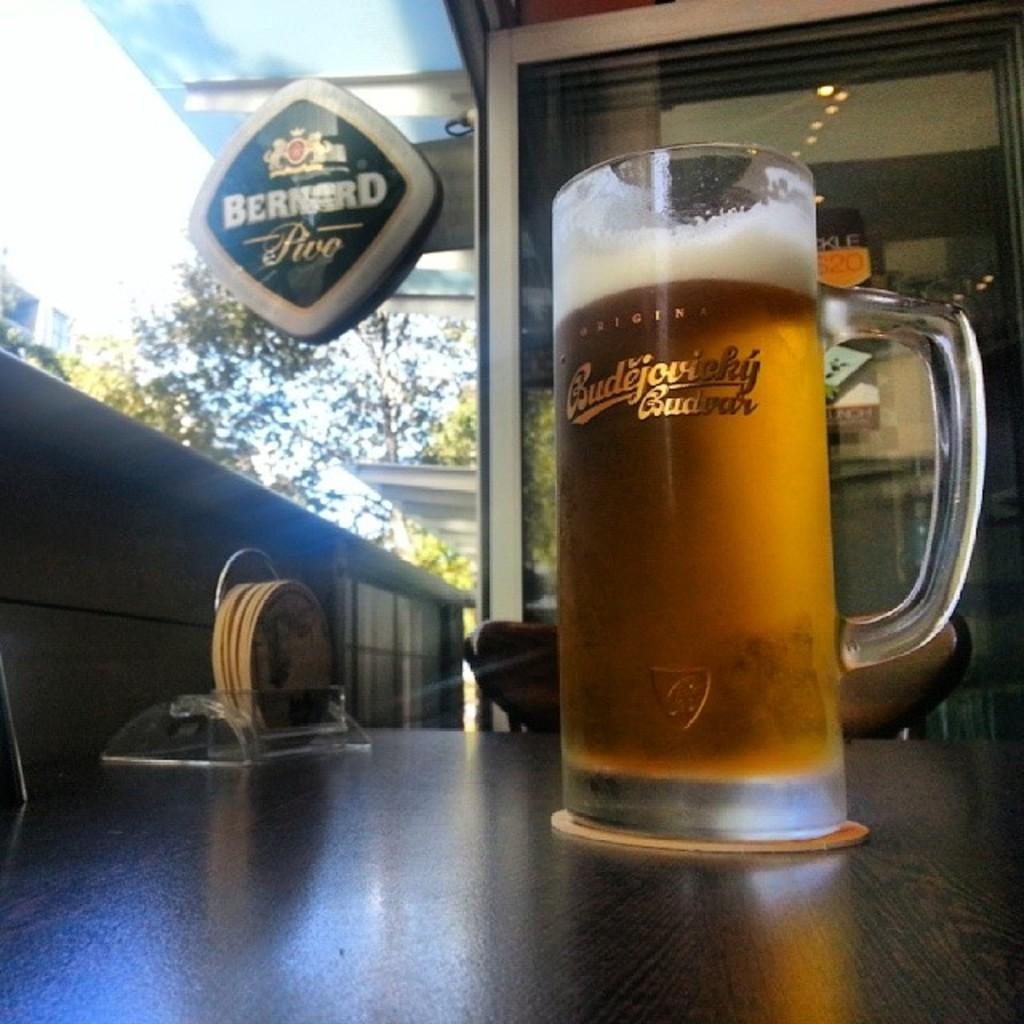<image>
Create a compact narrative representing the image presented. a beer is in a large stein at Bernards bar 